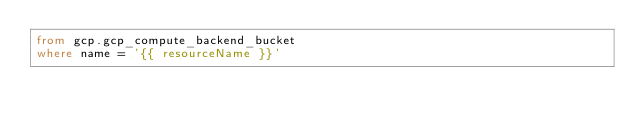<code> <loc_0><loc_0><loc_500><loc_500><_SQL_>from gcp.gcp_compute_backend_bucket
where name = '{{ resourceName }}'</code> 